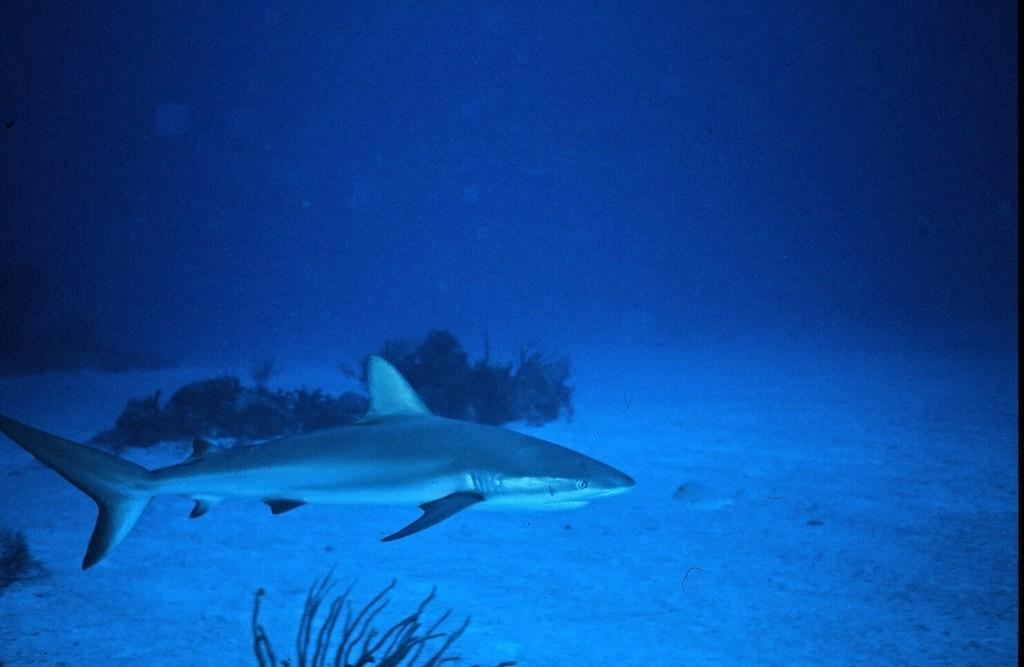What is located on the left side of the image? There is a fish on the left side of the image. What is the fish doing in the image? The fish is in the water. What type of vegetation is present on the left side of the image? There are aquatic plants on the left side of the image. What is the primary element visible in the image? There is water visible in the image. How many ladybugs can be seen on the fish in the image? There are no ladybugs present in the image; it features a fish in the water with aquatic plants. 